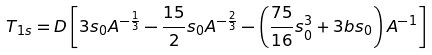<formula> <loc_0><loc_0><loc_500><loc_500>T _ { 1 s } = D \left [ 3 s _ { 0 } A ^ { - \frac { 1 } { 3 } } - \frac { 1 5 } 2 s _ { 0 } A ^ { - \frac { 2 } { 3 } } - \left ( \frac { 7 5 } { 1 6 } s _ { 0 } ^ { 3 } + 3 b s _ { 0 } \right ) A ^ { - 1 } \right ]</formula> 